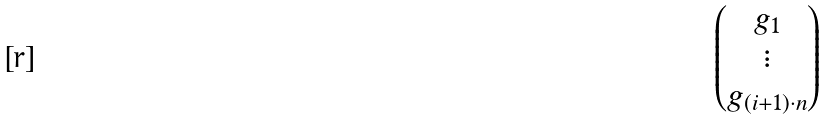Convert formula to latex. <formula><loc_0><loc_0><loc_500><loc_500>\begin{pmatrix} g _ { 1 } \\ \vdots \\ g _ { ( i + 1 ) \cdot n } \end{pmatrix}</formula> 